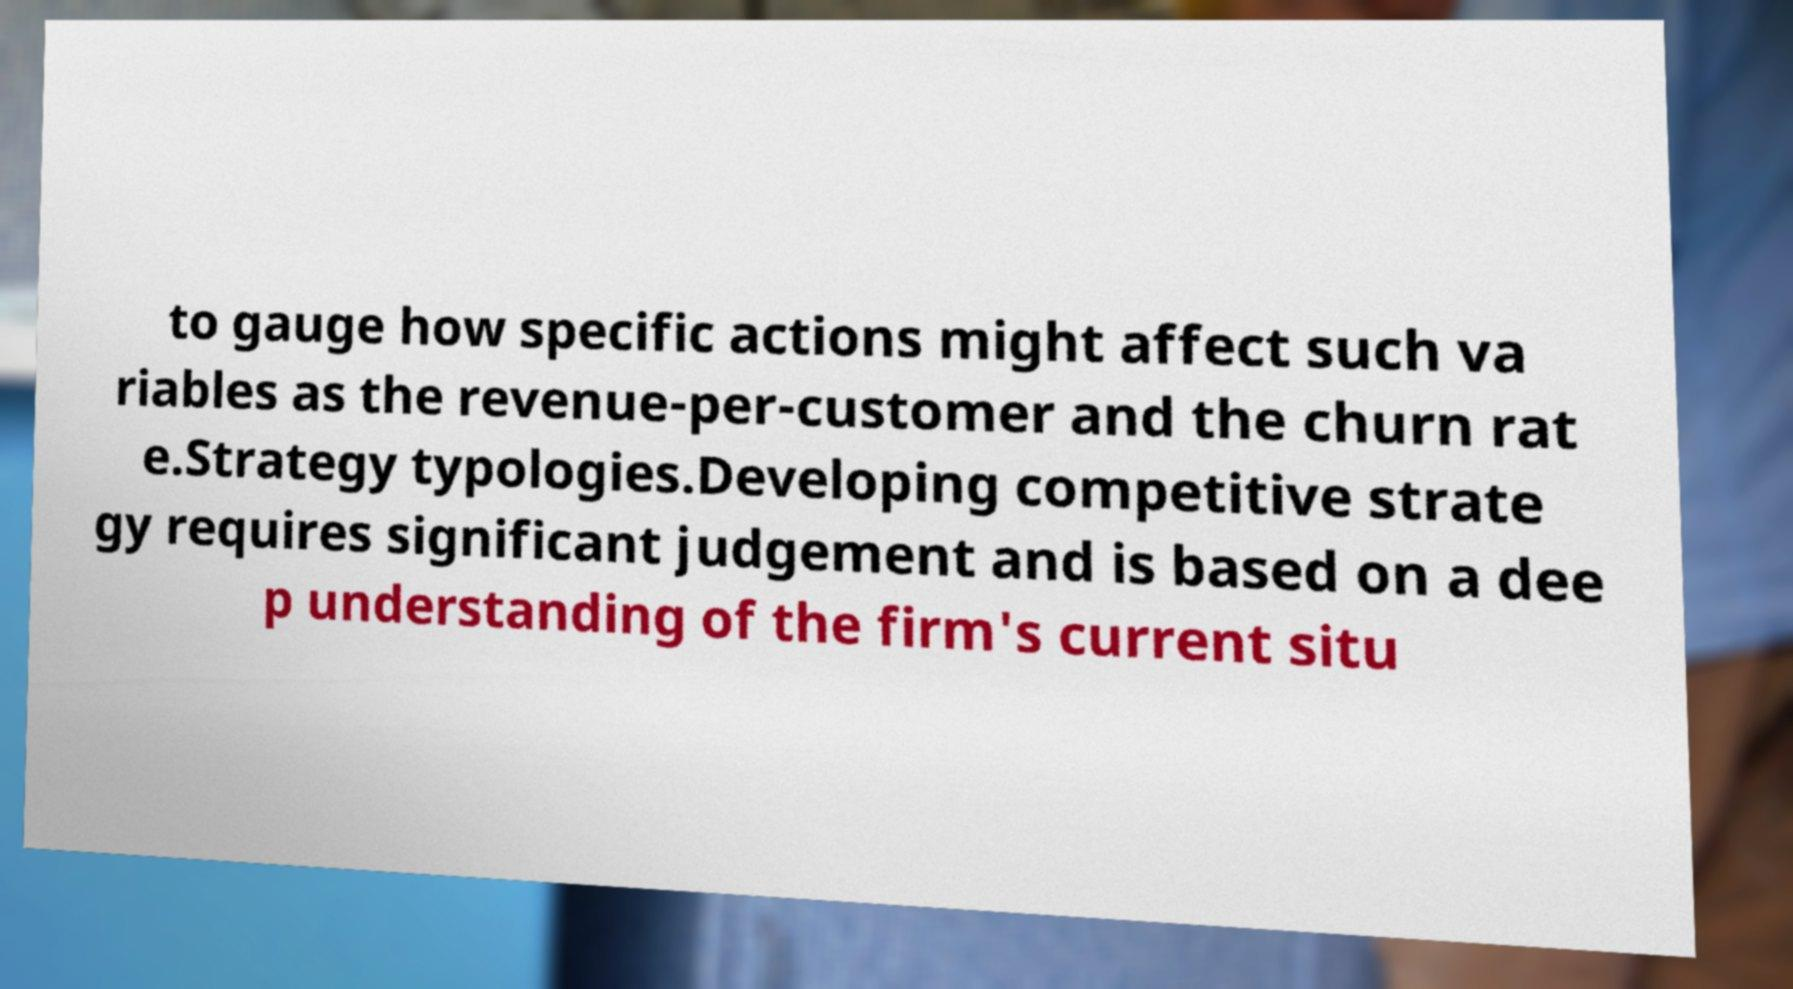Can you accurately transcribe the text from the provided image for me? to gauge how specific actions might affect such va riables as the revenue-per-customer and the churn rat e.Strategy typologies.Developing competitive strate gy requires significant judgement and is based on a dee p understanding of the firm's current situ 